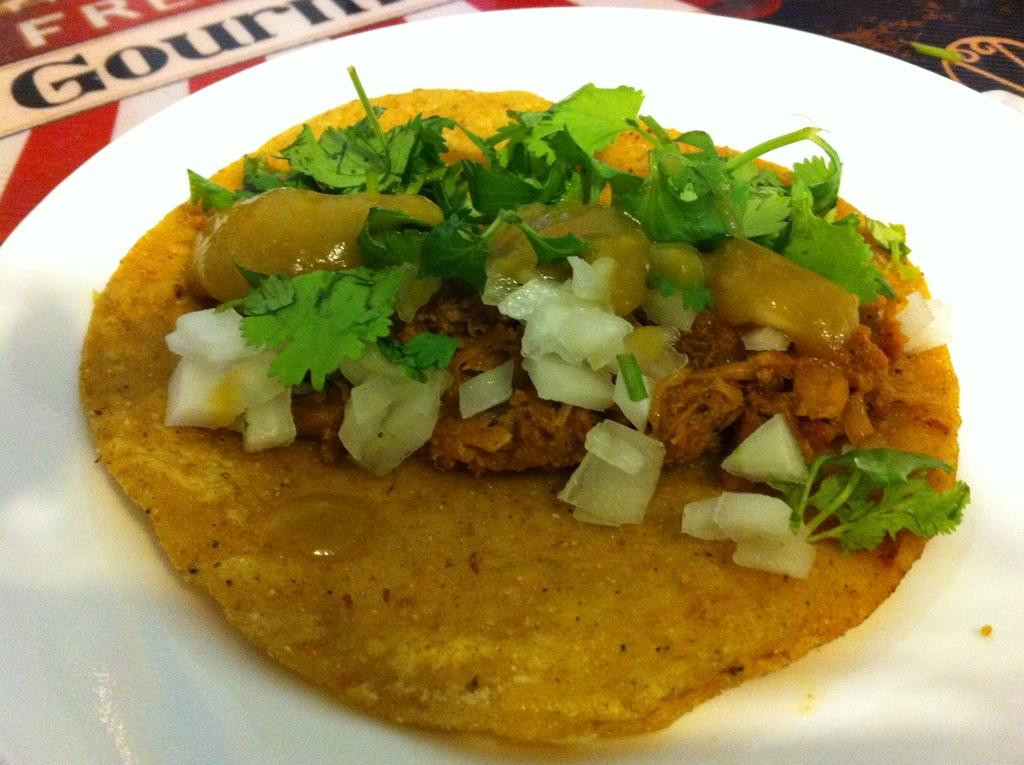What is placed on a serving plate in the image? There is food placed on a serving plate in the image. Can you see a snail crawling on the food in the image? No, there is no snail present in the image. 